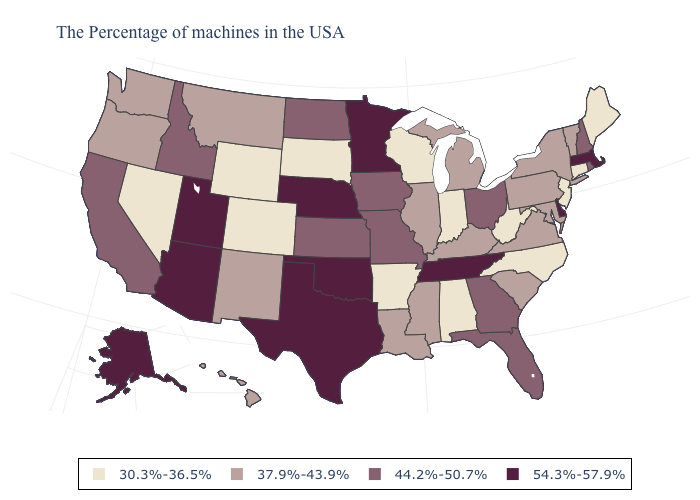Name the states that have a value in the range 37.9%-43.9%?
Give a very brief answer. Vermont, New York, Maryland, Pennsylvania, Virginia, South Carolina, Michigan, Kentucky, Illinois, Mississippi, Louisiana, New Mexico, Montana, Washington, Oregon, Hawaii. What is the value of Nevada?
Give a very brief answer. 30.3%-36.5%. Name the states that have a value in the range 37.9%-43.9%?
Quick response, please. Vermont, New York, Maryland, Pennsylvania, Virginia, South Carolina, Michigan, Kentucky, Illinois, Mississippi, Louisiana, New Mexico, Montana, Washington, Oregon, Hawaii. Does Tennessee have the highest value in the South?
Quick response, please. Yes. What is the value of Colorado?
Be succinct. 30.3%-36.5%. Among the states that border Massachusetts , which have the lowest value?
Answer briefly. Connecticut. Does the map have missing data?
Give a very brief answer. No. Name the states that have a value in the range 44.2%-50.7%?
Quick response, please. Rhode Island, New Hampshire, Ohio, Florida, Georgia, Missouri, Iowa, Kansas, North Dakota, Idaho, California. What is the highest value in the USA?
Give a very brief answer. 54.3%-57.9%. Which states have the lowest value in the MidWest?
Write a very short answer. Indiana, Wisconsin, South Dakota. Does Utah have the lowest value in the USA?
Keep it brief. No. What is the value of Georgia?
Give a very brief answer. 44.2%-50.7%. Does Oklahoma have the highest value in the USA?
Short answer required. Yes. Among the states that border Minnesota , which have the highest value?
Give a very brief answer. Iowa, North Dakota. Name the states that have a value in the range 30.3%-36.5%?
Short answer required. Maine, Connecticut, New Jersey, North Carolina, West Virginia, Indiana, Alabama, Wisconsin, Arkansas, South Dakota, Wyoming, Colorado, Nevada. 